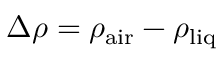Convert formula to latex. <formula><loc_0><loc_0><loc_500><loc_500>\Delta \rho = \rho _ { a i r } - \rho _ { l i q }</formula> 